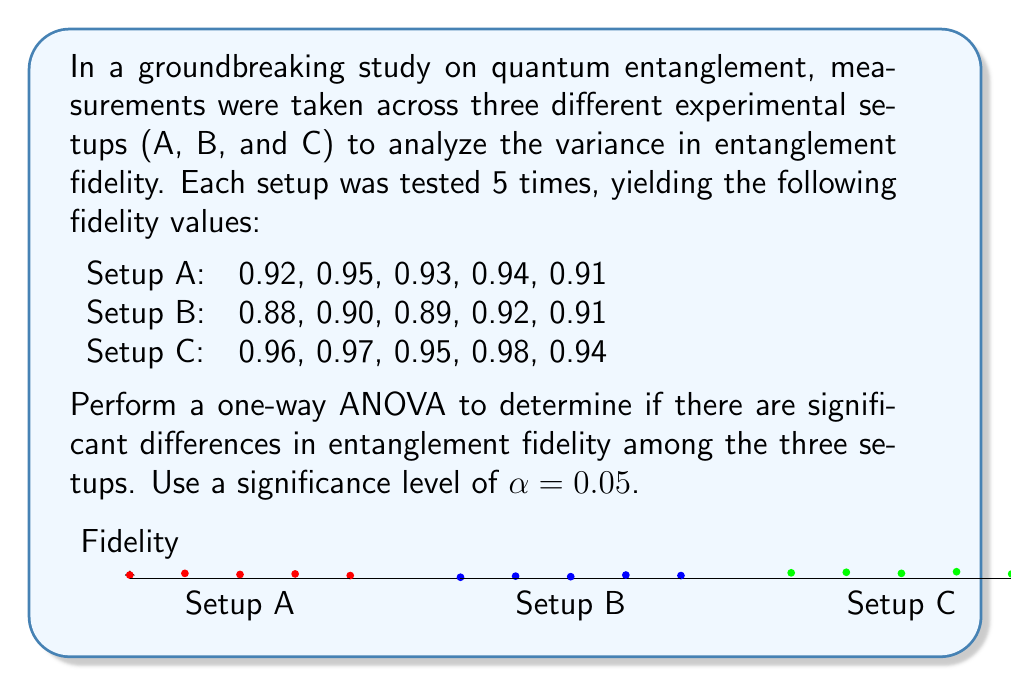Teach me how to tackle this problem. To perform a one-way ANOVA, we'll follow these steps:

1. Calculate the means for each group and the overall mean:
   $$\bar{X}_A = 0.93, \bar{X}_B = 0.90, \bar{X}_C = 0.96$$
   $$\bar{X}_{\text{overall}} = 0.93$$

2. Calculate the Sum of Squares Between (SSB):
   $$SSB = \sum_{i=1}^k n_i(\bar{X}_i - \bar{X}_{\text{overall}})^2$$
   $$SSB = 5(0.93 - 0.93)^2 + 5(0.90 - 0.93)^2 + 5(0.96 - 0.93)^2 = 0.0102$$

3. Calculate the Sum of Squares Within (SSW):
   $$SSW = \sum_{i=1}^k \sum_{j=1}^{n_i} (X_{ij} - \bar{X}_i)^2$$
   $$SSW = 0.0014 + 0.0014 + 0.0014 = 0.0042$$

4. Calculate the Sum of Squares Total (SST):
   $$SST = SSB + SSW = 0.0102 + 0.0042 = 0.0144$$

5. Calculate degrees of freedom:
   $$df_B = k - 1 = 2, df_W = N - k = 12, df_T = N - 1 = 14$$
   where $k$ is the number of groups and $N$ is the total number of observations.

6. Calculate Mean Squares:
   $$MSB = \frac{SSB}{df_B} = \frac{0.0102}{2} = 0.0051$$
   $$MSW = \frac{SSW}{df_W} = \frac{0.0042}{12} = 0.00035$$

7. Calculate the F-statistic:
   $$F = \frac{MSB}{MSW} = \frac{0.0051}{0.00035} = 14.57$$

8. Find the critical F-value:
   For α = 0.05, $df_B = 2$, and $df_W = 12$, the critical F-value is approximately 3.89.

9. Compare the F-statistic to the critical F-value:
   Since 14.57 > 3.89, we reject the null hypothesis.

Therefore, we conclude that there are significant differences in entanglement fidelity among the three experimental setups at the 0.05 significance level.
Answer: $F(2,12) = 14.57, p < 0.05$. Significant differences exist. 